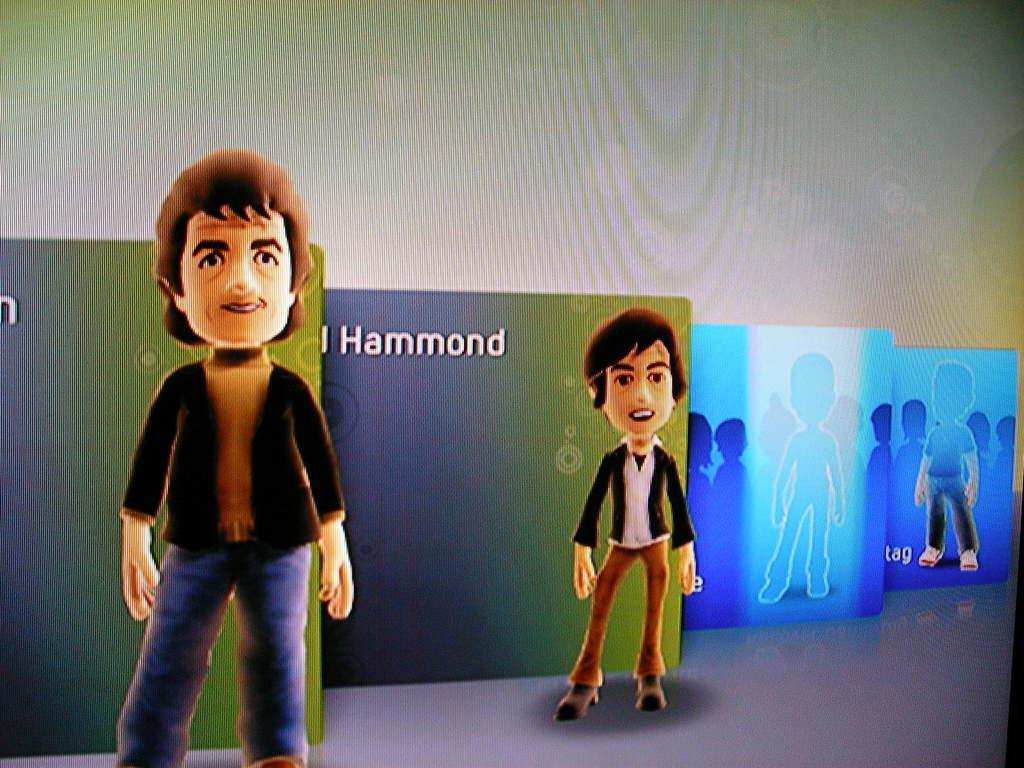In one or two sentences, can you explain what this image depicts? In this image I can see the animated picture and I can see two persons standing and I can see few frames and the background is in white color. 